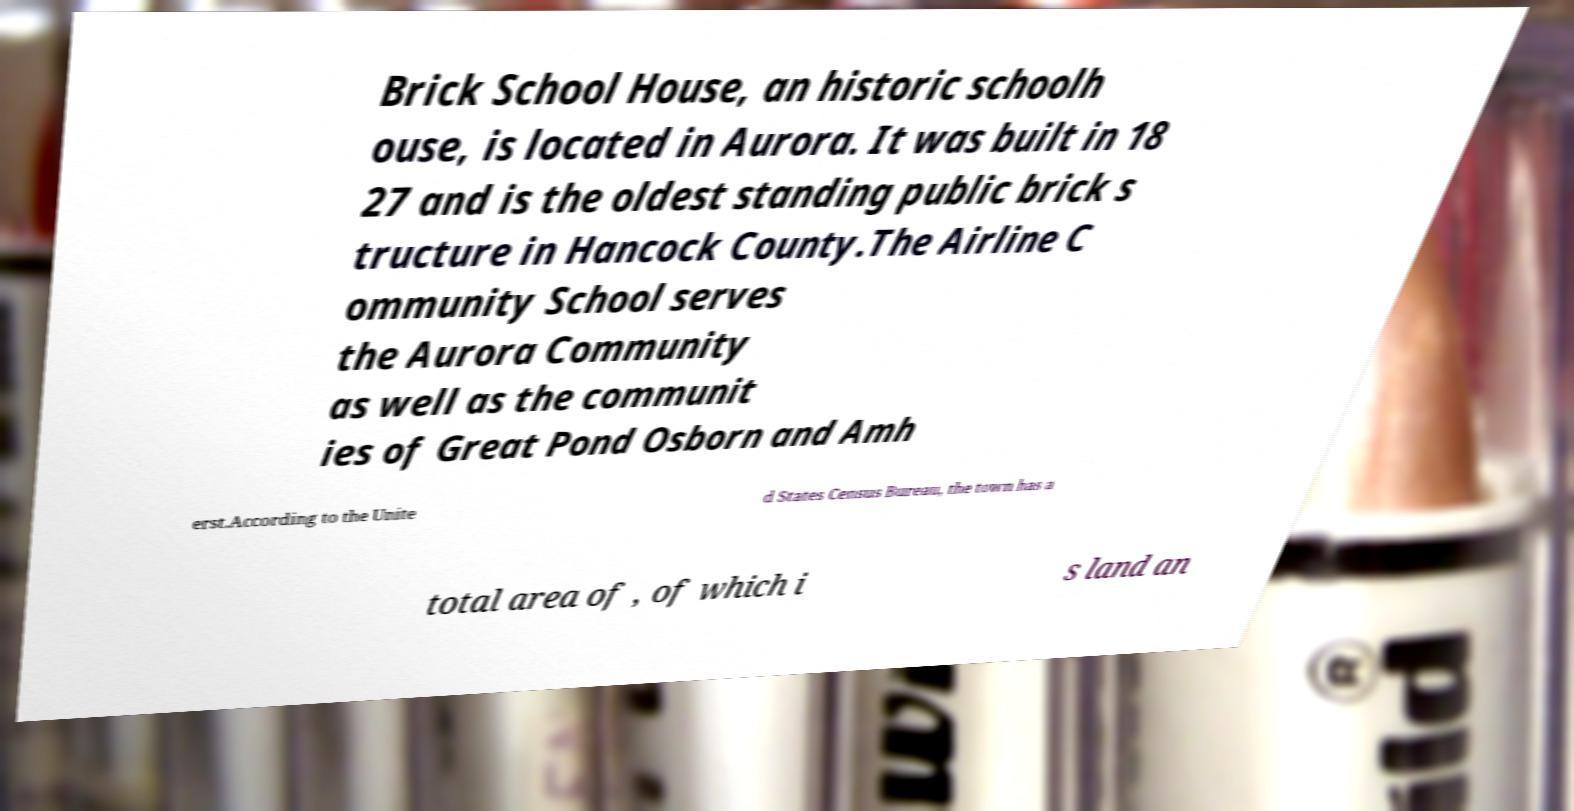What messages or text are displayed in this image? I need them in a readable, typed format. Brick School House, an historic schoolh ouse, is located in Aurora. It was built in 18 27 and is the oldest standing public brick s tructure in Hancock County.The Airline C ommunity School serves the Aurora Community as well as the communit ies of Great Pond Osborn and Amh erst.According to the Unite d States Census Bureau, the town has a total area of , of which i s land an 